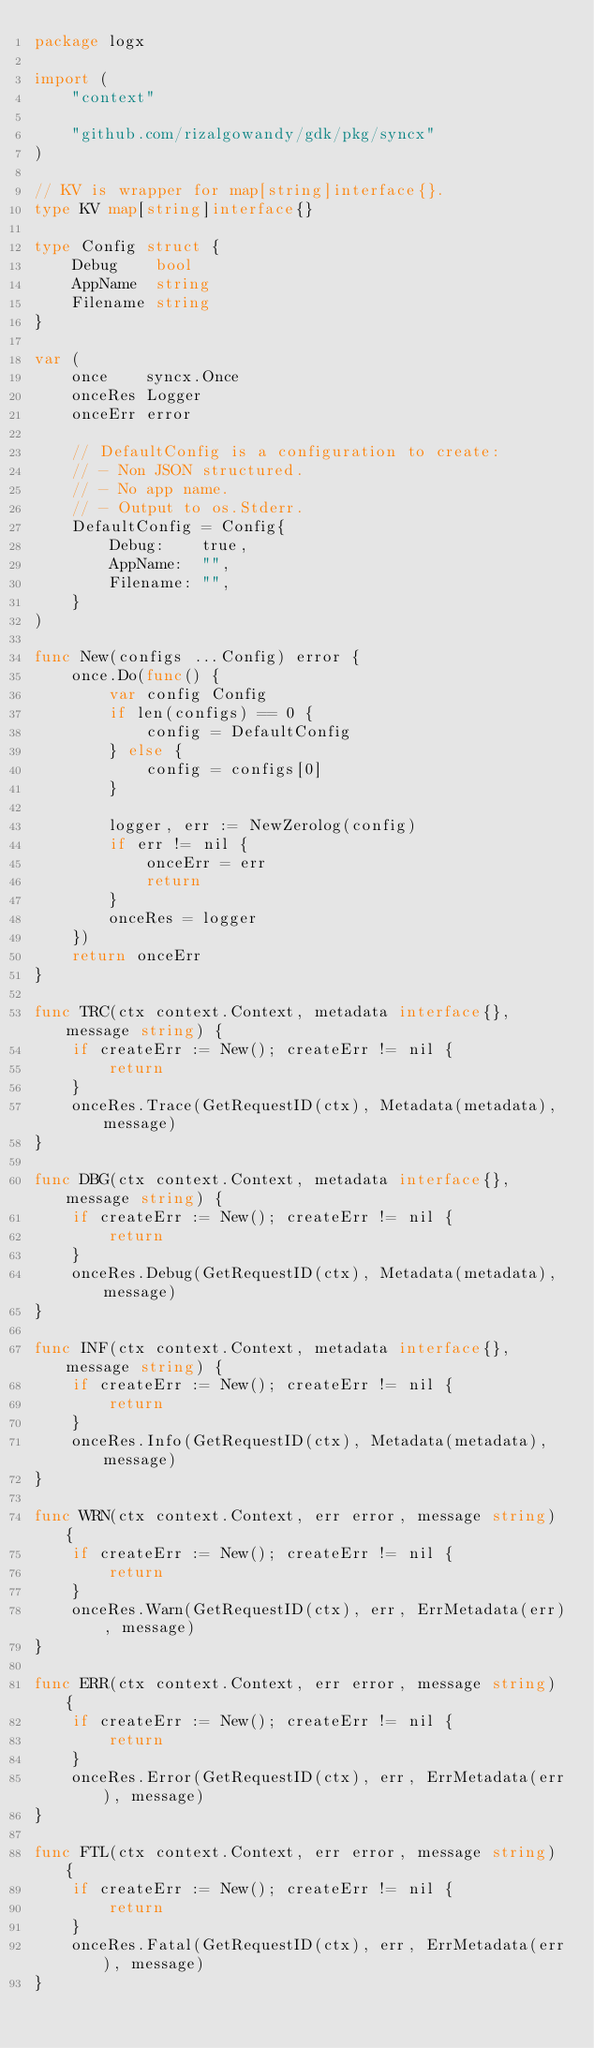Convert code to text. <code><loc_0><loc_0><loc_500><loc_500><_Go_>package logx

import (
	"context"

	"github.com/rizalgowandy/gdk/pkg/syncx"
)

// KV is wrapper for map[string]interface{}.
type KV map[string]interface{}

type Config struct {
	Debug    bool
	AppName  string
	Filename string
}

var (
	once    syncx.Once
	onceRes Logger
	onceErr error

	// DefaultConfig is a configuration to create:
	// - Non JSON structured.
	// - No app name.
	// - Output to os.Stderr.
	DefaultConfig = Config{
		Debug:    true,
		AppName:  "",
		Filename: "",
	}
)

func New(configs ...Config) error {
	once.Do(func() {
		var config Config
		if len(configs) == 0 {
			config = DefaultConfig
		} else {
			config = configs[0]
		}

		logger, err := NewZerolog(config)
		if err != nil {
			onceErr = err
			return
		}
		onceRes = logger
	})
	return onceErr
}

func TRC(ctx context.Context, metadata interface{}, message string) {
	if createErr := New(); createErr != nil {
		return
	}
	onceRes.Trace(GetRequestID(ctx), Metadata(metadata), message)
}

func DBG(ctx context.Context, metadata interface{}, message string) {
	if createErr := New(); createErr != nil {
		return
	}
	onceRes.Debug(GetRequestID(ctx), Metadata(metadata), message)
}

func INF(ctx context.Context, metadata interface{}, message string) {
	if createErr := New(); createErr != nil {
		return
	}
	onceRes.Info(GetRequestID(ctx), Metadata(metadata), message)
}

func WRN(ctx context.Context, err error, message string) {
	if createErr := New(); createErr != nil {
		return
	}
	onceRes.Warn(GetRequestID(ctx), err, ErrMetadata(err), message)
}

func ERR(ctx context.Context, err error, message string) {
	if createErr := New(); createErr != nil {
		return
	}
	onceRes.Error(GetRequestID(ctx), err, ErrMetadata(err), message)
}

func FTL(ctx context.Context, err error, message string) {
	if createErr := New(); createErr != nil {
		return
	}
	onceRes.Fatal(GetRequestID(ctx), err, ErrMetadata(err), message)
}
</code> 